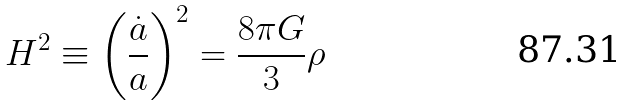Convert formula to latex. <formula><loc_0><loc_0><loc_500><loc_500>H ^ { 2 } \equiv \left ( \frac { \dot { a } } { a } \right ) ^ { 2 } = \frac { 8 \pi G } { 3 } \rho</formula> 